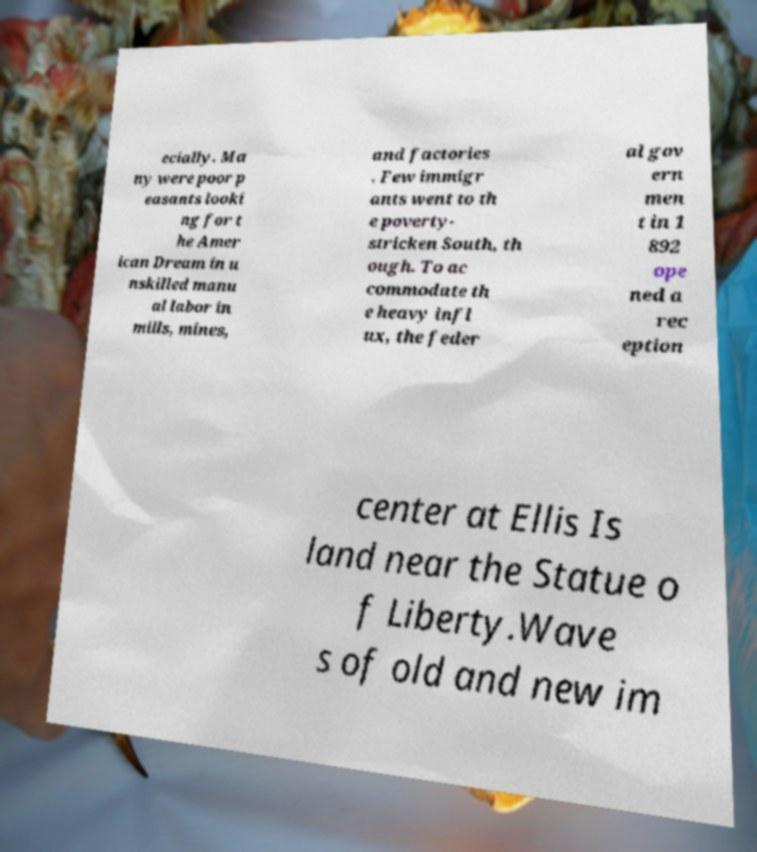Please read and relay the text visible in this image. What does it say? ecially. Ma ny were poor p easants looki ng for t he Amer ican Dream in u nskilled manu al labor in mills, mines, and factories . Few immigr ants went to th e poverty- stricken South, th ough. To ac commodate th e heavy infl ux, the feder al gov ern men t in 1 892 ope ned a rec eption center at Ellis Is land near the Statue o f Liberty.Wave s of old and new im 